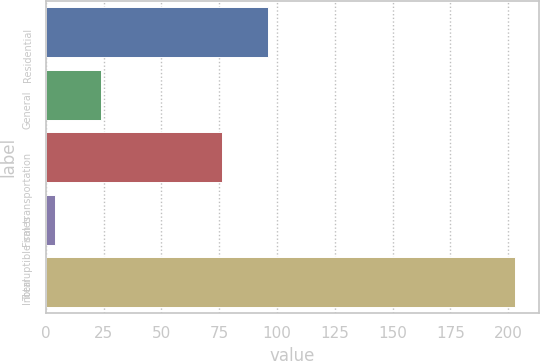Convert chart. <chart><loc_0><loc_0><loc_500><loc_500><bar_chart><fcel>Residential<fcel>General<fcel>Firm transportation<fcel>Interruptible sales<fcel>Total<nl><fcel>95.9<fcel>23.9<fcel>76<fcel>4<fcel>203<nl></chart> 